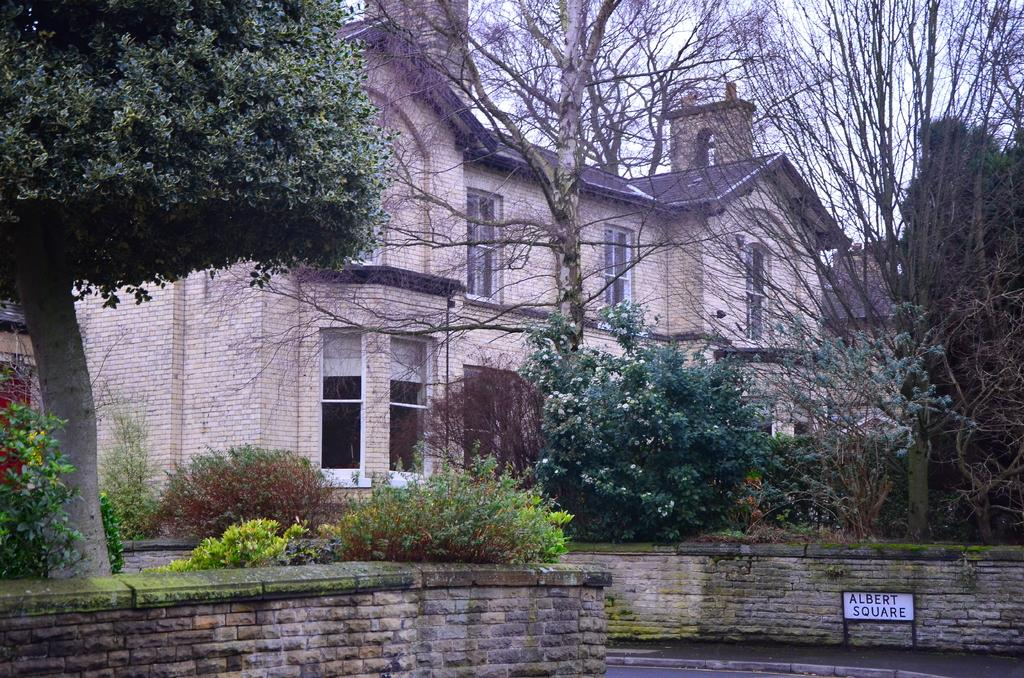What is the main object in the foreground of the image? There is a board in the image. What can be seen in the background of the image? There is a building, trees, plants, and the sky visible in the background of the image. What type of glove is the beggar wearing in the image? There is no beggar or glove present in the image. What time of day is it in the image, considering the afternoon? The time of day cannot be determined from the image, as there is no indication of the time. 